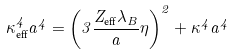Convert formula to latex. <formula><loc_0><loc_0><loc_500><loc_500>\kappa ^ { 4 } _ { \text {eff} } a ^ { 4 } = \left ( 3 \frac { Z _ { \text {eff} } \lambda _ { B } } { a } \eta \right ) ^ { 2 } + \kappa ^ { 4 } a ^ { 4 }</formula> 